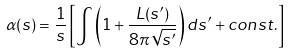<formula> <loc_0><loc_0><loc_500><loc_500>\alpha ( s ) = \frac { 1 } { s } \left [ \int \left ( 1 + \frac { L ( s ^ { \prime } ) } { 8 \pi \sqrt { s ^ { \prime } } } \right ) d s ^ { \prime } + c o n s t . \right ]</formula> 